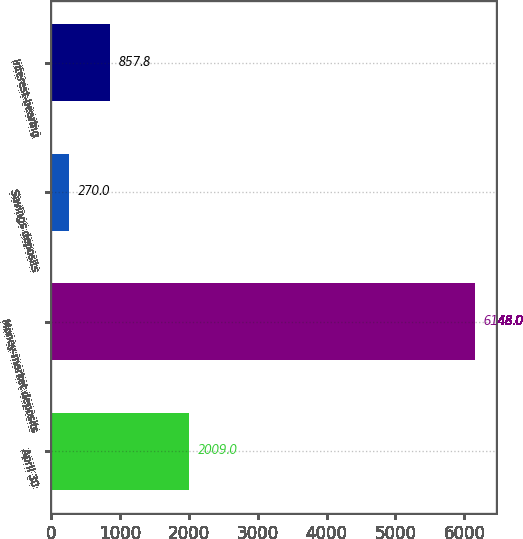Convert chart. <chart><loc_0><loc_0><loc_500><loc_500><bar_chart><fcel>April 30<fcel>Money-market deposits<fcel>Savings deposits<fcel>Interest-bearing<nl><fcel>2009<fcel>6148<fcel>270<fcel>857.8<nl></chart> 